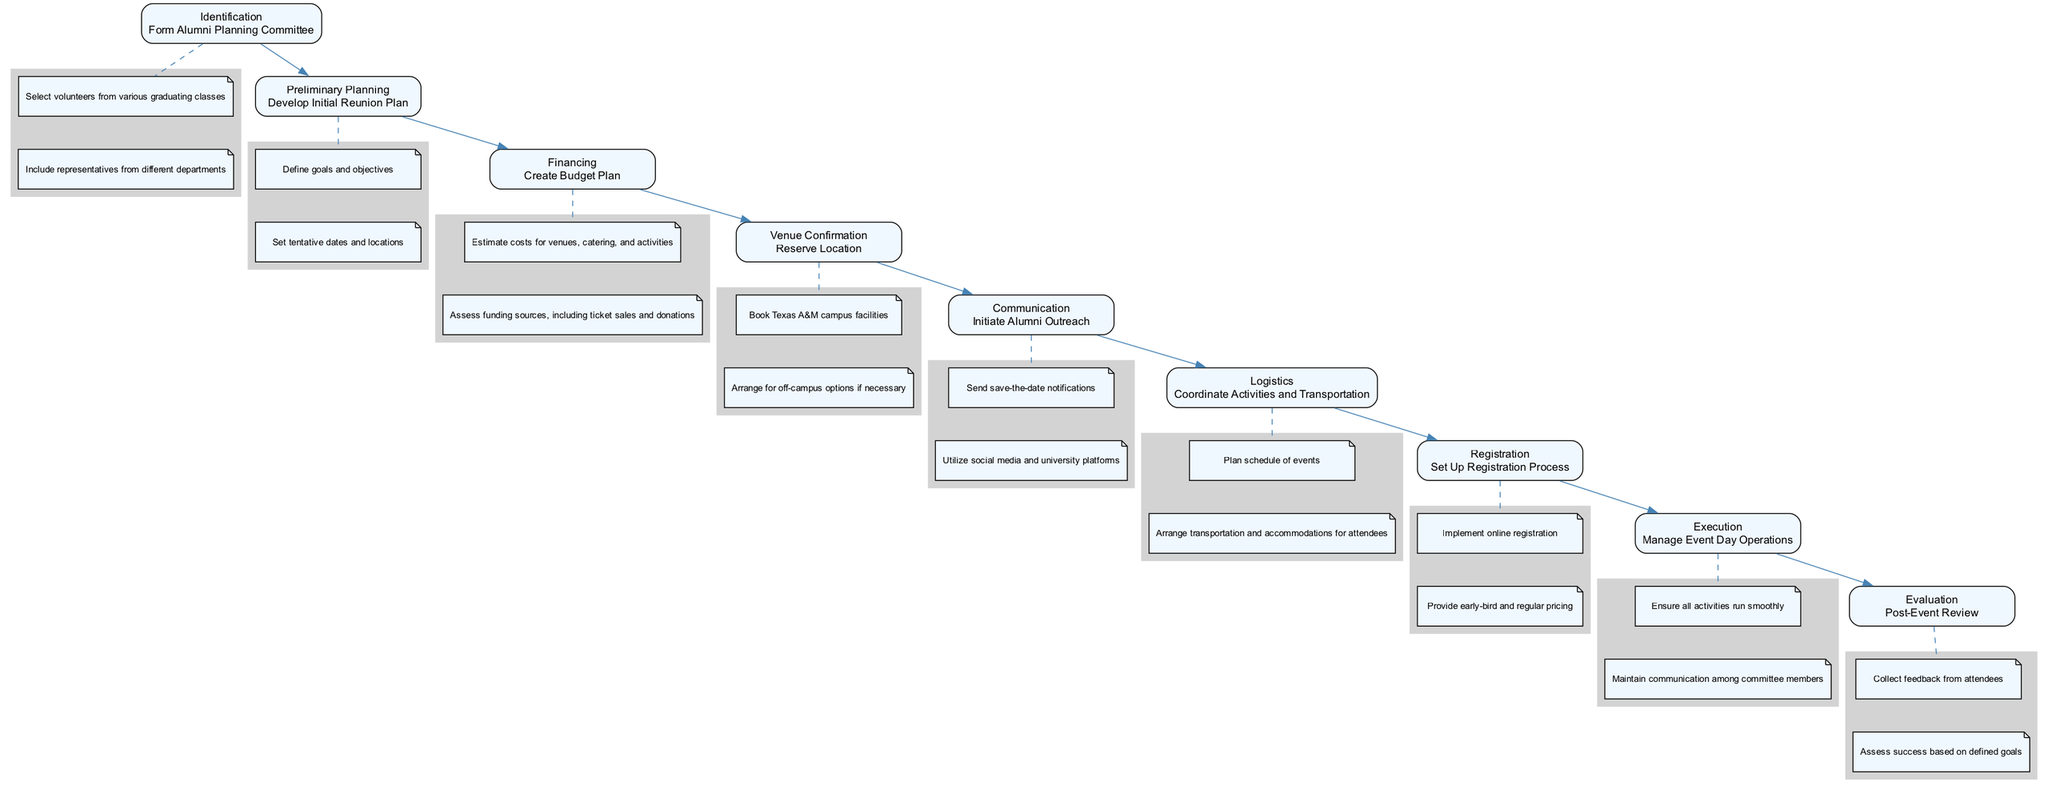What is the first task in the pathway? The first task in the pathway is specified under the "Identification" stage, which is to "Form Alumni Planning Committee." This is indicated as the lead step in the sequence.
Answer: Form Alumni Planning Committee How many stages are there in total? The total number of stages is counted from "Identification" to "Evaluation." There are nine distinct stages noted in the diagram.
Answer: 9 What task comes after "Financing"? The task that follows "Financing" is "Venue Confirmation." This can be traced directly along the pathways of the diagram.
Answer: Venue Confirmation Which stage involves sending notifications? The task involving sending notifications occurs in the "Communication" stage where "Initiate Alumni Outreach" is performed. This is specified under that stage's details.
Answer: Communication What is one financing source mentioned? In the "Financing" stage, one financing source mentioned is "ticket sales." This is explicitly stated in the budget planning details.
Answer: ticket sales How many details are listed under "Execution"? In the "Execution" stage, there are two details provided: "Ensure all activities run smoothly" and "Maintain communication among committee members." This can be verified by reviewing the listed details under that stage.
Answer: 2 What task must be completed before "Logistics"? The task that must be completed before "Logistics" is "Registration." The sequence of the diagram shows "Registration" connected directly before "Logistics."
Answer: Registration Which stage does the post-event review belong to? The post-event review belongs to the "Evaluation" stage, as indicated in the pathway where "Post-Event Review" is listed under that stage.
Answer: Evaluation What is the main goal of the "Preliminary Planning"? The main goal of the "Preliminary Planning" is to "Develop Initial Reunion Plan," which includes defining goals and objectives. This provides insight into the purpose of that stage.
Answer: Develop Initial Reunion Plan 